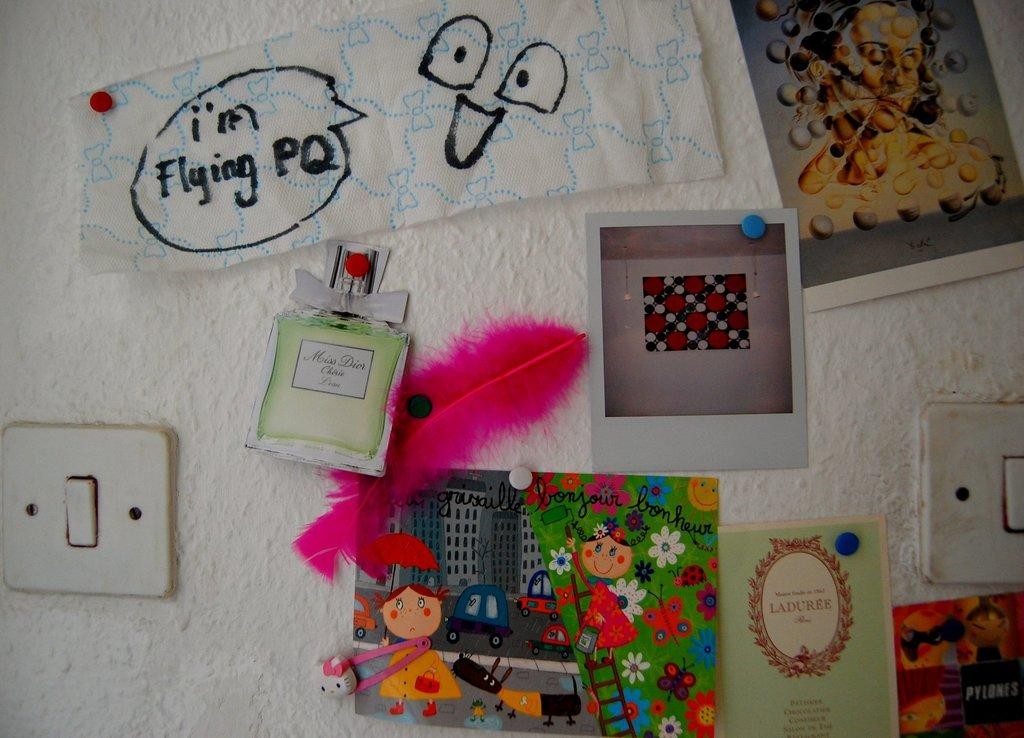<image>
Give a short and clear explanation of the subsequent image. A wall filled with pictures and cut outs of Miss Dior perfume 